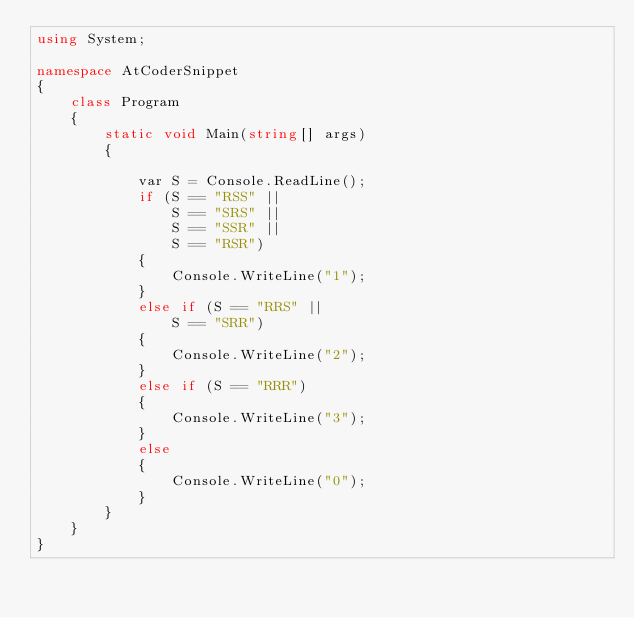<code> <loc_0><loc_0><loc_500><loc_500><_C#_>using System;

namespace AtCoderSnippet
{
    class Program
    {
        static void Main(string[] args)
        {

            var S = Console.ReadLine();
            if (S == "RSS" ||
                S == "SRS" ||
                S == "SSR" ||
                S == "RSR")
            {
                Console.WriteLine("1");
            }
            else if (S == "RRS" ||
                S == "SRR")
            {
                Console.WriteLine("2");
            }
            else if (S == "RRR")
            {
                Console.WriteLine("3");
            }
            else
            {
                Console.WriteLine("0");
            }
        }
    }
}
</code> 